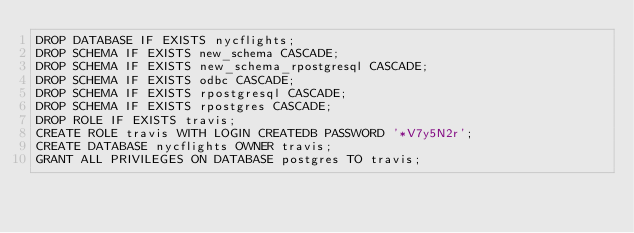Convert code to text. <code><loc_0><loc_0><loc_500><loc_500><_SQL_>DROP DATABASE IF EXISTS nycflights;
DROP SCHEMA IF EXISTS new_schema CASCADE;
DROP SCHEMA IF EXISTS new_schema_rpostgresql CASCADE;
DROP SCHEMA IF EXISTS odbc CASCADE;
DROP SCHEMA IF EXISTS rpostgresql CASCADE;
DROP SCHEMA IF EXISTS rpostgres CASCADE;
DROP ROLE IF EXISTS travis;
CREATE ROLE travis WITH LOGIN CREATEDB PASSWORD '*V7y5N2r';
CREATE DATABASE nycflights OWNER travis;
GRANT ALL PRIVILEGES ON DATABASE postgres TO travis;
</code> 